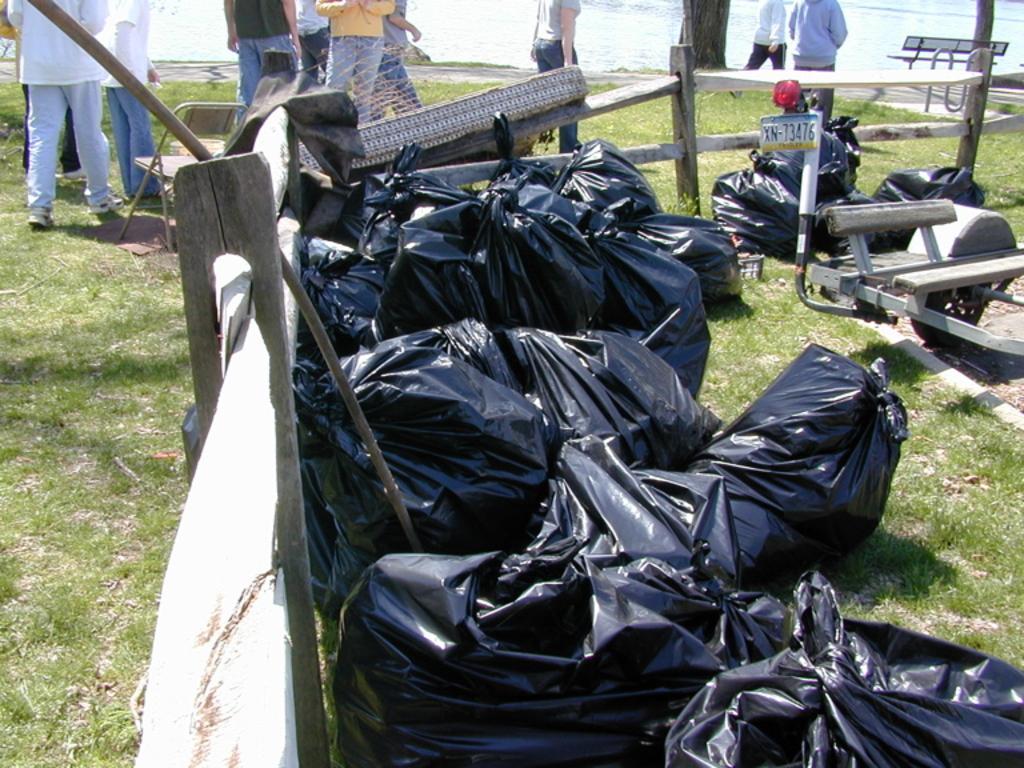Describe this image in one or two sentences. In the image there are few black cover bags inside wooden fence and behind there are few people walking on the grassland followed by a lake. 